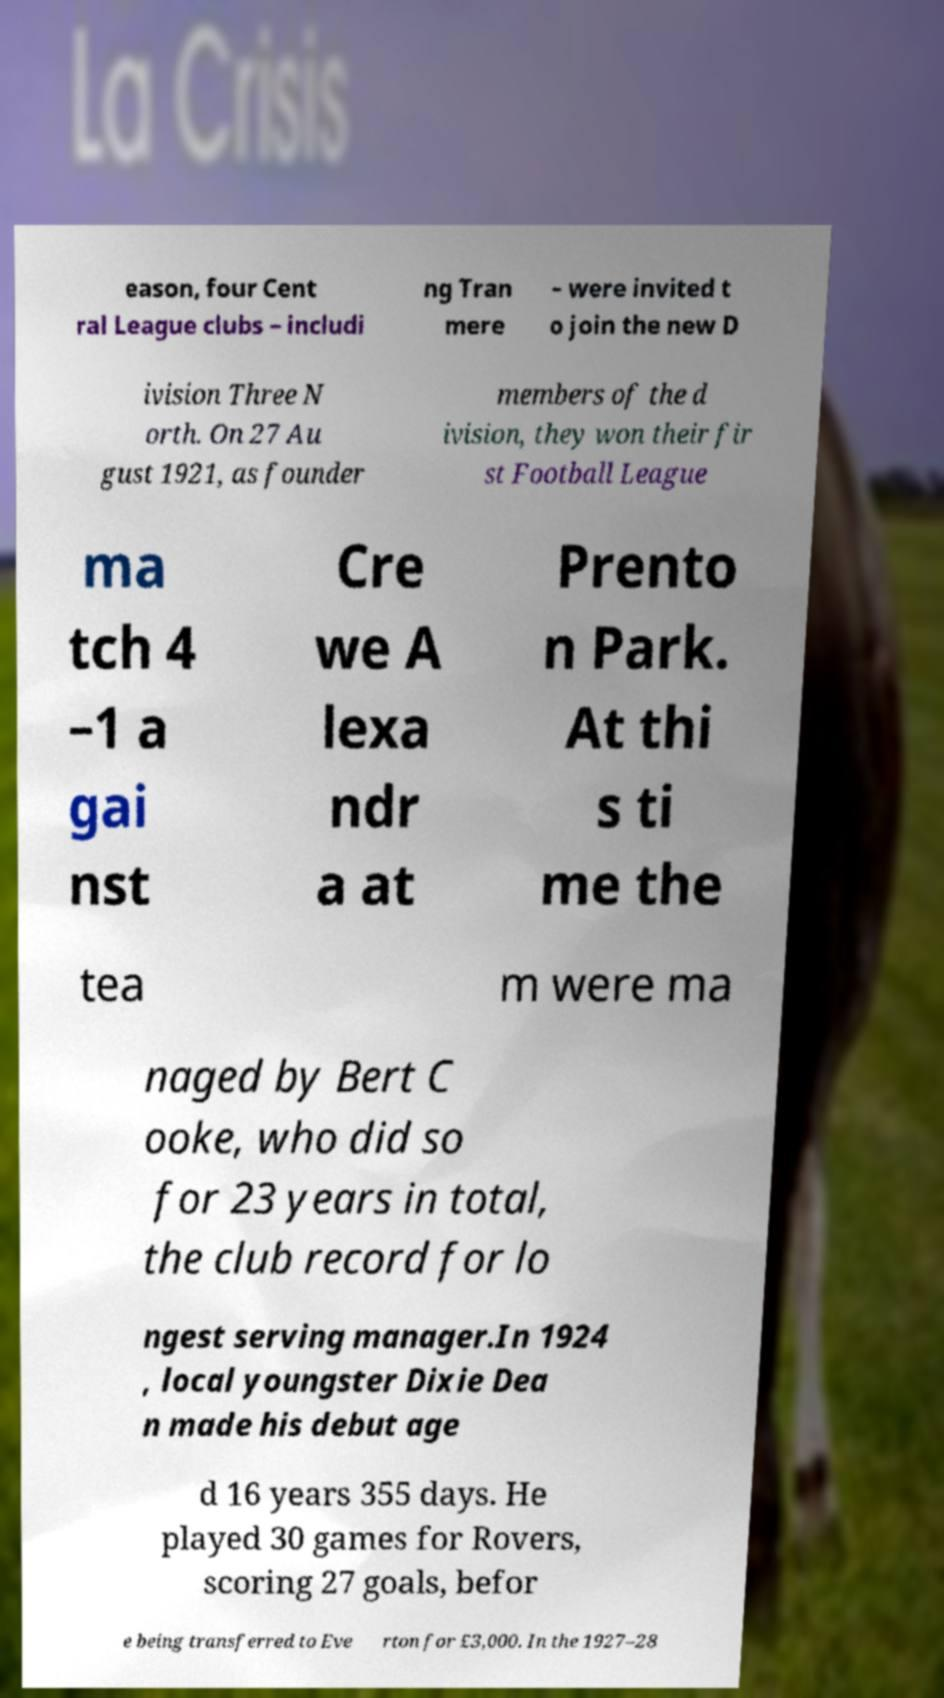I need the written content from this picture converted into text. Can you do that? eason, four Cent ral League clubs – includi ng Tran mere – were invited t o join the new D ivision Three N orth. On 27 Au gust 1921, as founder members of the d ivision, they won their fir st Football League ma tch 4 –1 a gai nst Cre we A lexa ndr a at Prento n Park. At thi s ti me the tea m were ma naged by Bert C ooke, who did so for 23 years in total, the club record for lo ngest serving manager.In 1924 , local youngster Dixie Dea n made his debut age d 16 years 355 days. He played 30 games for Rovers, scoring 27 goals, befor e being transferred to Eve rton for £3,000. In the 1927–28 